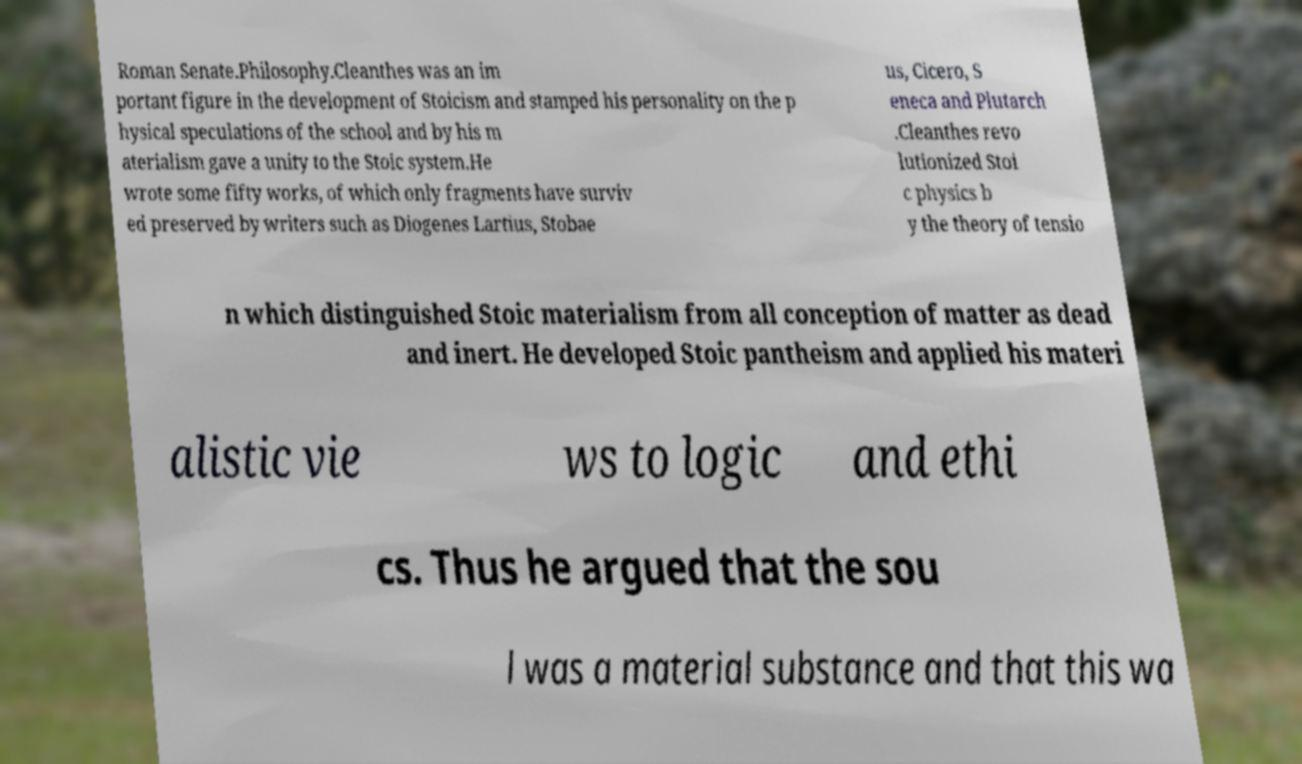Can you read and provide the text displayed in the image?This photo seems to have some interesting text. Can you extract and type it out for me? Roman Senate.Philosophy.Cleanthes was an im portant figure in the development of Stoicism and stamped his personality on the p hysical speculations of the school and by his m aterialism gave a unity to the Stoic system.He wrote some fifty works, of which only fragments have surviv ed preserved by writers such as Diogenes Lartius, Stobae us, Cicero, S eneca and Plutarch .Cleanthes revo lutionized Stoi c physics b y the theory of tensio n which distinguished Stoic materialism from all conception of matter as dead and inert. He developed Stoic pantheism and applied his materi alistic vie ws to logic and ethi cs. Thus he argued that the sou l was a material substance and that this wa 